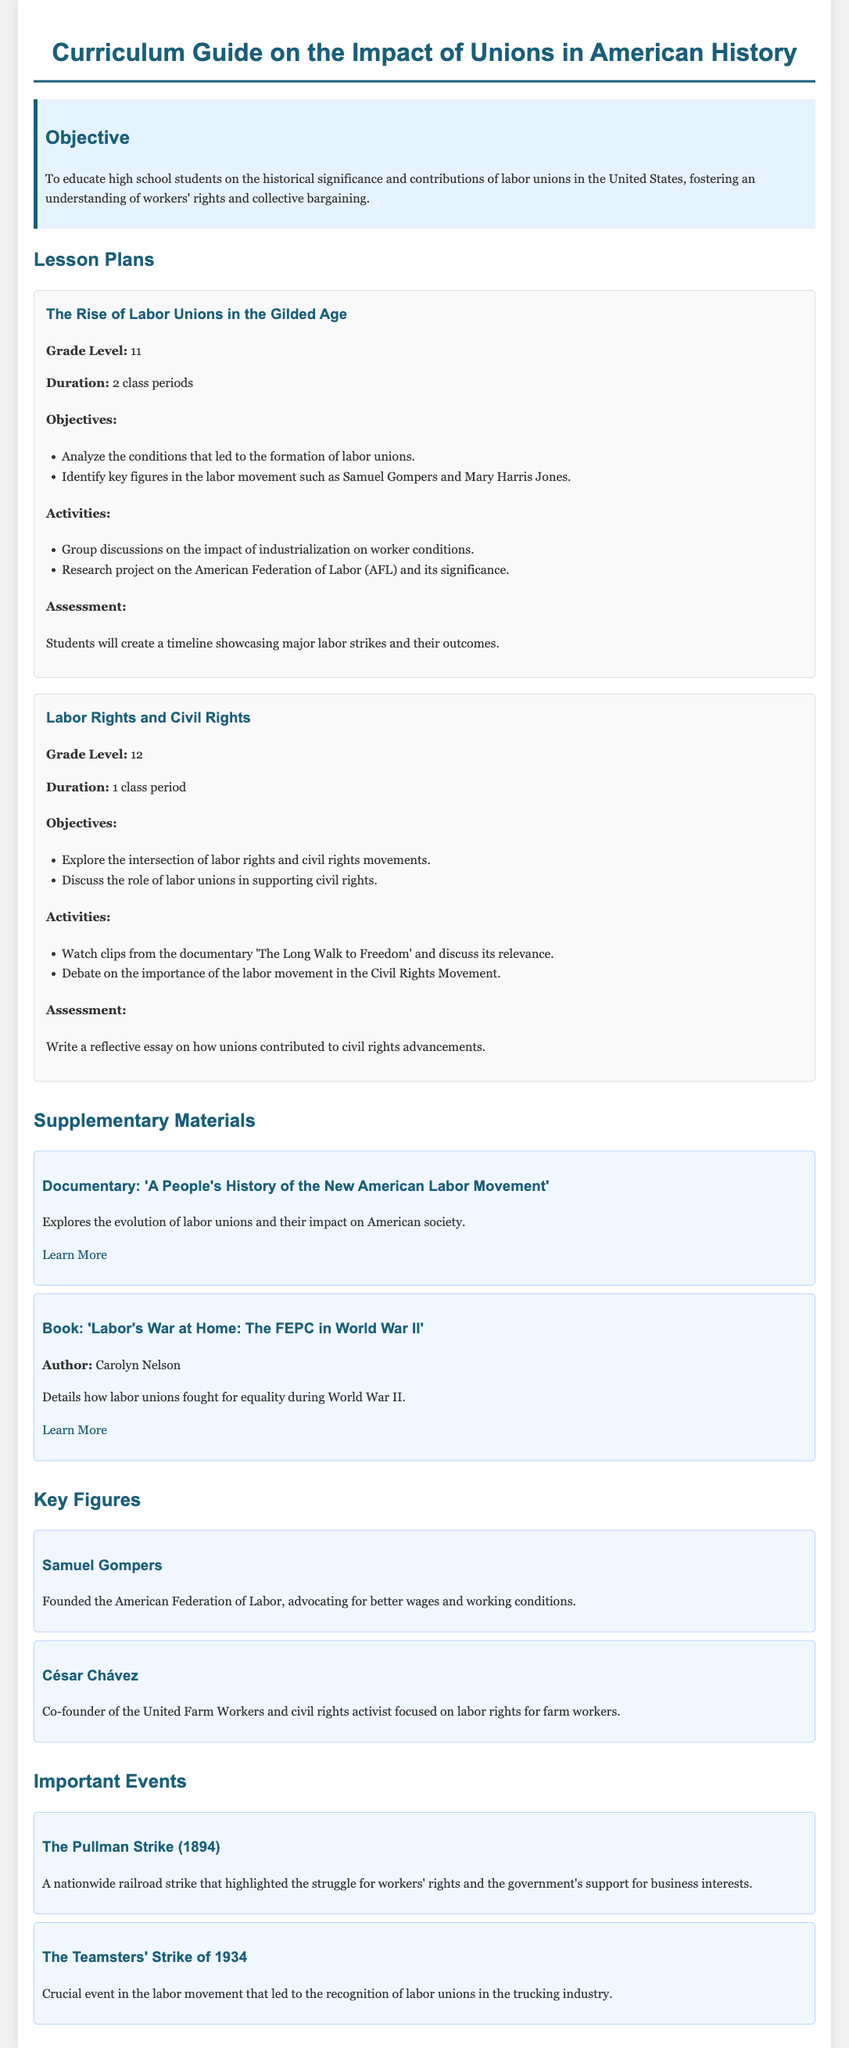What is the main objective of this curriculum guide? The objective is to educate high school students on the historical significance and contributions of labor unions in the United States, fostering an understanding of workers' rights and collective bargaining.
Answer: To educate high school students on the historical significance and contributions of labor unions in the United States What grade level is the lesson plan "The Rise of Labor Unions in the Gilded Age" intended for? The lesson plan specifies that it is designed for 11th grade students.
Answer: 11 Who were two key figures in the labor movement mentioned in the first lesson plan? The lesson plan highlights Samuel Gompers and Mary Harris Jones as key figures in the labor movement.
Answer: Samuel Gompers and Mary Harris Jones In what year did the Pullman Strike occur? The document states that the Pullman Strike happened in 1894.
Answer: 1894 What type of assessment is used in the "Labor Rights and Civil Rights" lesson plan? The lesson plan requires students to write a reflective essay as an assessment for understanding labor rights and civil rights.
Answer: Reflective essay Which documentary is listed as supplementary material? The curriculum guide includes the documentary 'A People's History of the New American Labor Movement' as supplementary material.
Answer: 'A People's History of the New American Labor Movement' What important event did the Teamsters' Strike of 1934 lead to? It led to the recognition of labor unions in the trucking industry.
Answer: Recognition of labor unions in the trucking industry What is one of the activities listed for the lesson on "Labor Rights and Civil Rights"? One of the activities involves watching clips from the documentary 'The Long Walk to Freedom' and discussing its relevance.
Answer: Watch documentary clips and discuss relevance 